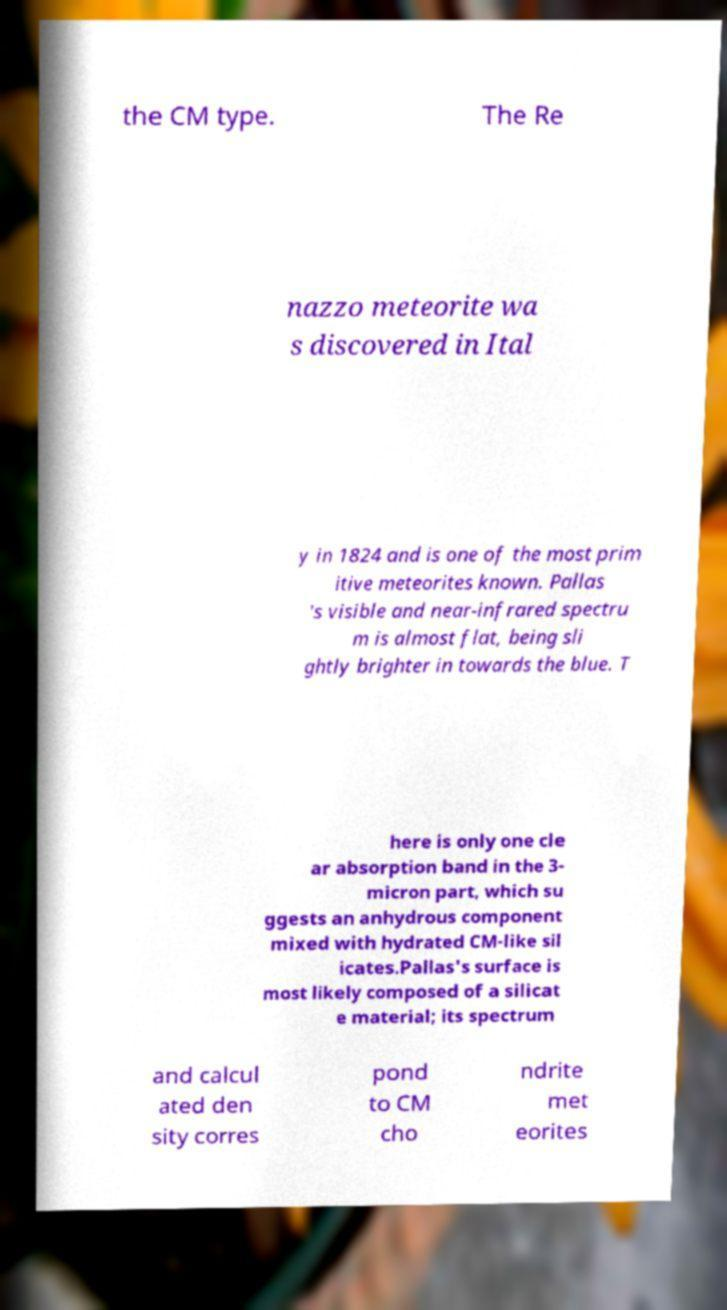For documentation purposes, I need the text within this image transcribed. Could you provide that? the CM type. The Re nazzo meteorite wa s discovered in Ital y in 1824 and is one of the most prim itive meteorites known. Pallas 's visible and near-infrared spectru m is almost flat, being sli ghtly brighter in towards the blue. T here is only one cle ar absorption band in the 3- micron part, which su ggests an anhydrous component mixed with hydrated CM-like sil icates.Pallas's surface is most likely composed of a silicat e material; its spectrum and calcul ated den sity corres pond to CM cho ndrite met eorites 